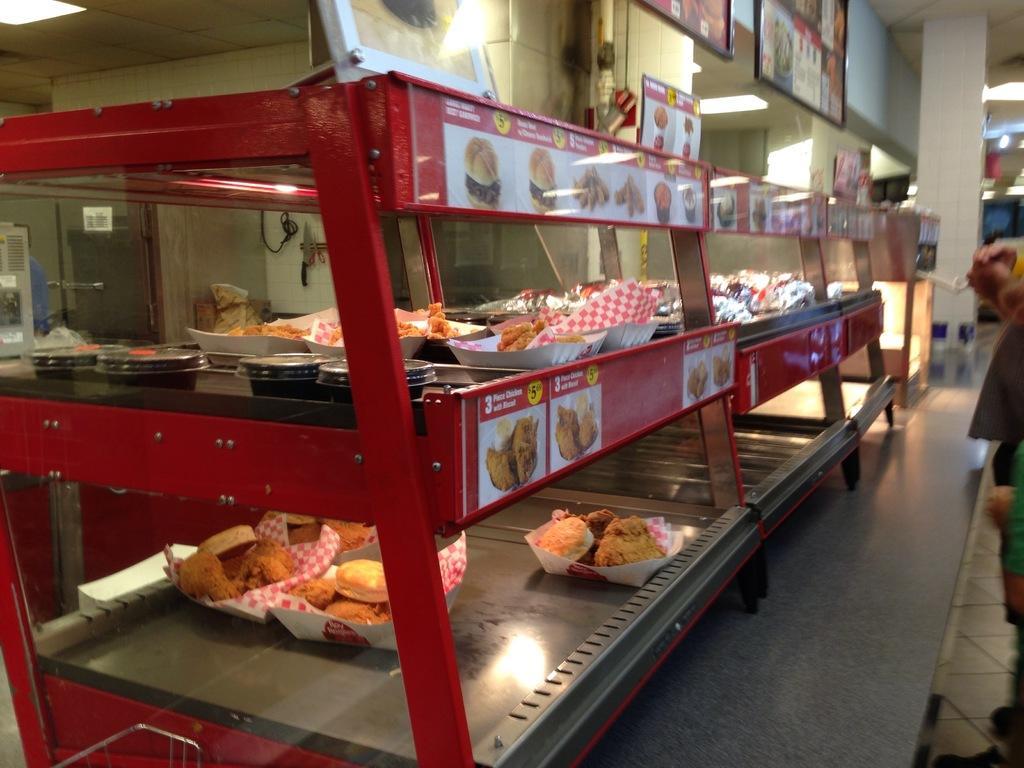Could you give a brief overview of what you see in this image? As we can see in the image there are sweets, refrigerator, photo frame and wall. 